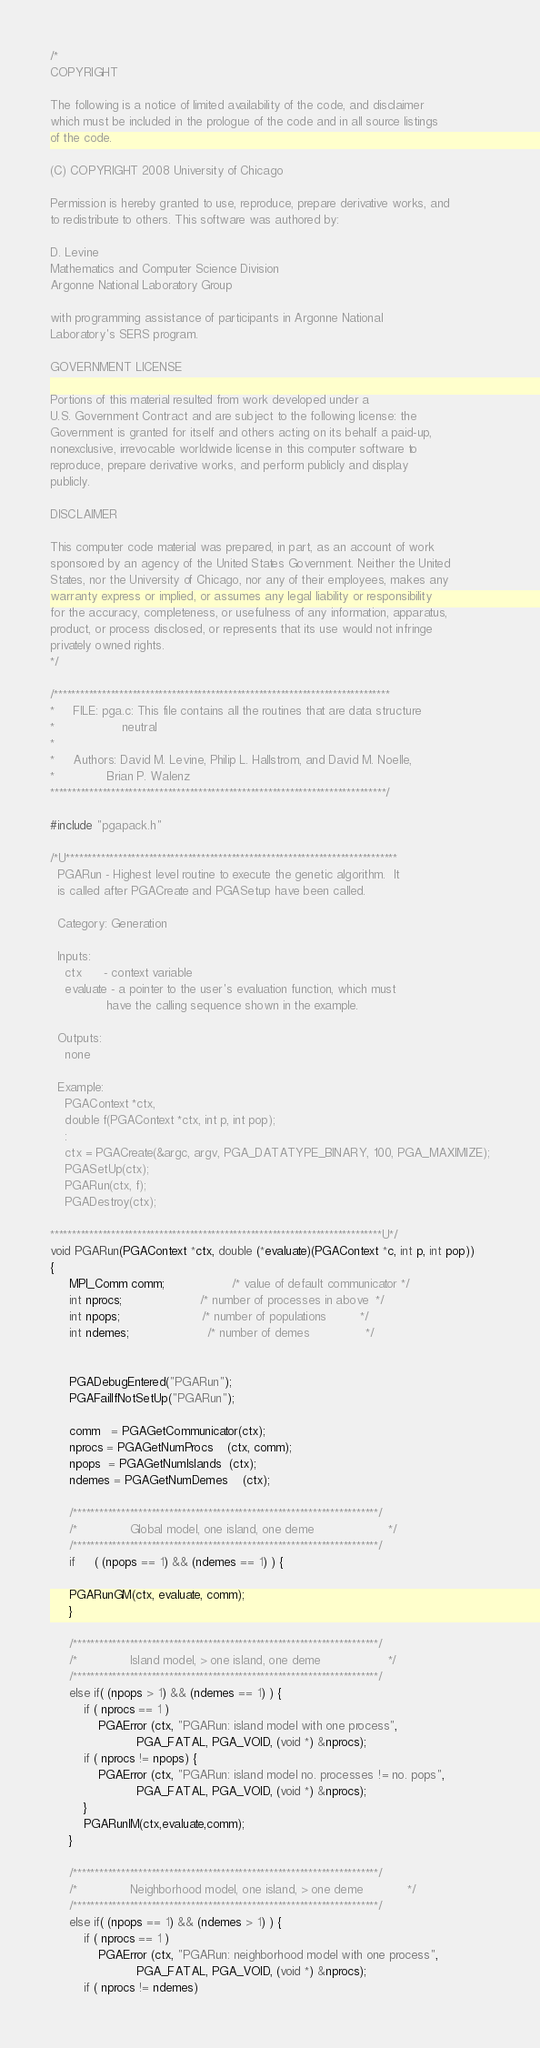Convert code to text. <code><loc_0><loc_0><loc_500><loc_500><_C_>/*
COPYRIGHT

The following is a notice of limited availability of the code, and disclaimer
which must be included in the prologue of the code and in all source listings
of the code.

(C) COPYRIGHT 2008 University of Chicago

Permission is hereby granted to use, reproduce, prepare derivative works, and
to redistribute to others. This software was authored by:

D. Levine
Mathematics and Computer Science Division 
Argonne National Laboratory Group

with programming assistance of participants in Argonne National 
Laboratory's SERS program.

GOVERNMENT LICENSE

Portions of this material resulted from work developed under a
U.S. Government Contract and are subject to the following license: the
Government is granted for itself and others acting on its behalf a paid-up,
nonexclusive, irrevocable worldwide license in this computer software to
reproduce, prepare derivative works, and perform publicly and display
publicly.

DISCLAIMER

This computer code material was prepared, in part, as an account of work
sponsored by an agency of the United States Government. Neither the United
States, nor the University of Chicago, nor any of their employees, makes any
warranty express or implied, or assumes any legal liability or responsibility
for the accuracy, completeness, or usefulness of any information, apparatus,
product, or process disclosed, or represents that its use would not infringe
privately owned rights.
*/

/*****************************************************************************
*     FILE: pga.c: This file contains all the routines that are data structure
*                  neutral
*
*     Authors: David M. Levine, Philip L. Hallstrom, and David M. Noelle,
*              Brian P. Walenz
*****************************************************************************/

#include "pgapack.h"

/*U****************************************************************************
  PGARun - Highest level routine to execute the genetic algorithm.  It
  is called after PGACreate and PGASetup have been called.

  Category: Generation

  Inputs:
    ctx      - context variable
    evaluate - a pointer to the user's evaluation function, which must
               have the calling sequence shown in the example.

  Outputs:
    none

  Example:
    PGAContext *ctx,
    double f(PGAContext *ctx, int p, int pop);
    :
    ctx = PGACreate(&argc, argv, PGA_DATATYPE_BINARY, 100, PGA_MAXIMIZE);
    PGASetUp(ctx);
    PGARun(ctx, f);
    PGADestroy(ctx);

****************************************************************************U*/
void PGARun(PGAContext *ctx, double (*evaluate)(PGAContext *c, int p, int pop))
{
     MPI_Comm comm;                  /* value of default communicator */
     int nprocs;                     /* number of processes in above  */
     int npops;                      /* number of populations         */
     int ndemes;                     /* number of demes               */
     

     PGADebugEntered("PGARun");
     PGAFailIfNotSetUp("PGARun");

     comm   = PGAGetCommunicator(ctx);
     nprocs = PGAGetNumProcs    (ctx, comm);
     npops  = PGAGetNumIslands  (ctx);
     ndemes = PGAGetNumDemes    (ctx);

     /**********************************************************************/
     /*              Global model, one island, one deme                    */
     /**********************************************************************/
     if     ( (npops == 1) && (ndemes == 1) ) {

	 PGARunGM(ctx, evaluate, comm);
     }
     
     /**********************************************************************/
     /*              Island model, > one island, one deme                  */
     /**********************************************************************/
     else if( (npops > 1) && (ndemes == 1) ) {
         if ( nprocs == 1 )
             PGAError (ctx, "PGARun: island model with one process",
                       PGA_FATAL, PGA_VOID, (void *) &nprocs);
         if ( nprocs != npops) {
             PGAError (ctx, "PGARun: island model no. processes != no. pops",
                       PGA_FATAL, PGA_VOID, (void *) &nprocs);
         }
         PGARunIM(ctx,evaluate,comm);
     }
             
     /**********************************************************************/
     /*              Neighborhood model, one island, > one deme            */
     /**********************************************************************/
     else if( (npops == 1) && (ndemes > 1) ) {
         if ( nprocs == 1 )
             PGAError (ctx, "PGARun: neighborhood model with one process",
                       PGA_FATAL, PGA_VOID, (void *) &nprocs);
         if ( nprocs != ndemes)</code> 